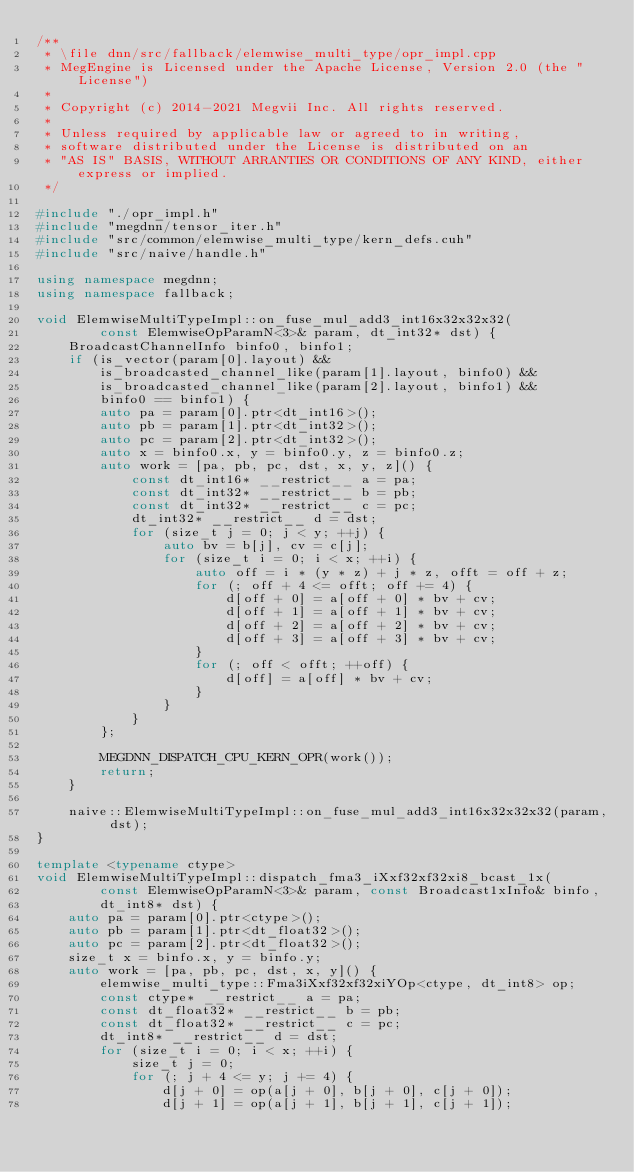<code> <loc_0><loc_0><loc_500><loc_500><_C++_>/**
 * \file dnn/src/fallback/elemwise_multi_type/opr_impl.cpp
 * MegEngine is Licensed under the Apache License, Version 2.0 (the "License")
 *
 * Copyright (c) 2014-2021 Megvii Inc. All rights reserved.
 *
 * Unless required by applicable law or agreed to in writing,
 * software distributed under the License is distributed on an
 * "AS IS" BASIS, WITHOUT ARRANTIES OR CONDITIONS OF ANY KIND, either express or implied.
 */

#include "./opr_impl.h"
#include "megdnn/tensor_iter.h"
#include "src/common/elemwise_multi_type/kern_defs.cuh"
#include "src/naive/handle.h"

using namespace megdnn;
using namespace fallback;

void ElemwiseMultiTypeImpl::on_fuse_mul_add3_int16x32x32x32(
        const ElemwiseOpParamN<3>& param, dt_int32* dst) {
    BroadcastChannelInfo binfo0, binfo1;
    if (is_vector(param[0].layout) &&
        is_broadcasted_channel_like(param[1].layout, binfo0) &&
        is_broadcasted_channel_like(param[2].layout, binfo1) &&
        binfo0 == binfo1) {
        auto pa = param[0].ptr<dt_int16>();
        auto pb = param[1].ptr<dt_int32>();
        auto pc = param[2].ptr<dt_int32>();
        auto x = binfo0.x, y = binfo0.y, z = binfo0.z;
        auto work = [pa, pb, pc, dst, x, y, z]() {
            const dt_int16* __restrict__ a = pa;
            const dt_int32* __restrict__ b = pb;
            const dt_int32* __restrict__ c = pc;
            dt_int32* __restrict__ d = dst;
            for (size_t j = 0; j < y; ++j) {
                auto bv = b[j], cv = c[j];
                for (size_t i = 0; i < x; ++i) {
                    auto off = i * (y * z) + j * z, offt = off + z;
                    for (; off + 4 <= offt; off += 4) {
                        d[off + 0] = a[off + 0] * bv + cv;
                        d[off + 1] = a[off + 1] * bv + cv;
                        d[off + 2] = a[off + 2] * bv + cv;
                        d[off + 3] = a[off + 3] * bv + cv;
                    }
                    for (; off < offt; ++off) {
                        d[off] = a[off] * bv + cv;
                    }
                }
            }
        };

        MEGDNN_DISPATCH_CPU_KERN_OPR(work());
        return;
    }

    naive::ElemwiseMultiTypeImpl::on_fuse_mul_add3_int16x32x32x32(param, dst);
}

template <typename ctype>
void ElemwiseMultiTypeImpl::dispatch_fma3_iXxf32xf32xi8_bcast_1x(
        const ElemwiseOpParamN<3>& param, const Broadcast1xInfo& binfo,
        dt_int8* dst) {
    auto pa = param[0].ptr<ctype>();
    auto pb = param[1].ptr<dt_float32>();
    auto pc = param[2].ptr<dt_float32>();
    size_t x = binfo.x, y = binfo.y;
    auto work = [pa, pb, pc, dst, x, y]() {
        elemwise_multi_type::Fma3iXxf32xf32xiYOp<ctype, dt_int8> op;
        const ctype* __restrict__ a = pa;
        const dt_float32* __restrict__ b = pb;
        const dt_float32* __restrict__ c = pc;
        dt_int8* __restrict__ d = dst;
        for (size_t i = 0; i < x; ++i) {
            size_t j = 0;
            for (; j + 4 <= y; j += 4) {
                d[j + 0] = op(a[j + 0], b[j + 0], c[j + 0]);
                d[j + 1] = op(a[j + 1], b[j + 1], c[j + 1]);</code> 